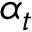Convert formula to latex. <formula><loc_0><loc_0><loc_500><loc_500>\alpha _ { t }</formula> 